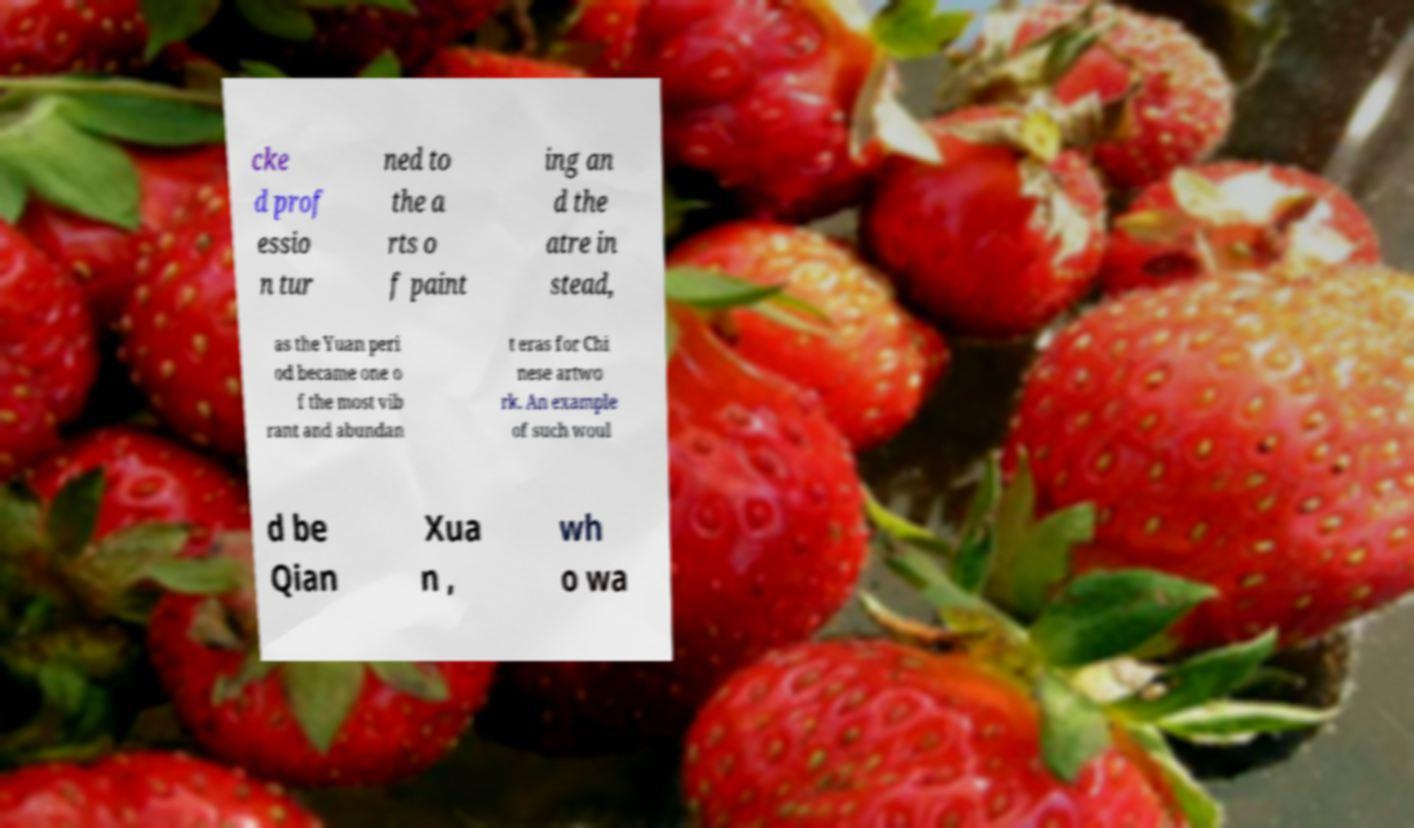I need the written content from this picture converted into text. Can you do that? cke d prof essio n tur ned to the a rts o f paint ing an d the atre in stead, as the Yuan peri od became one o f the most vib rant and abundan t eras for Chi nese artwo rk. An example of such woul d be Qian Xua n , wh o wa 